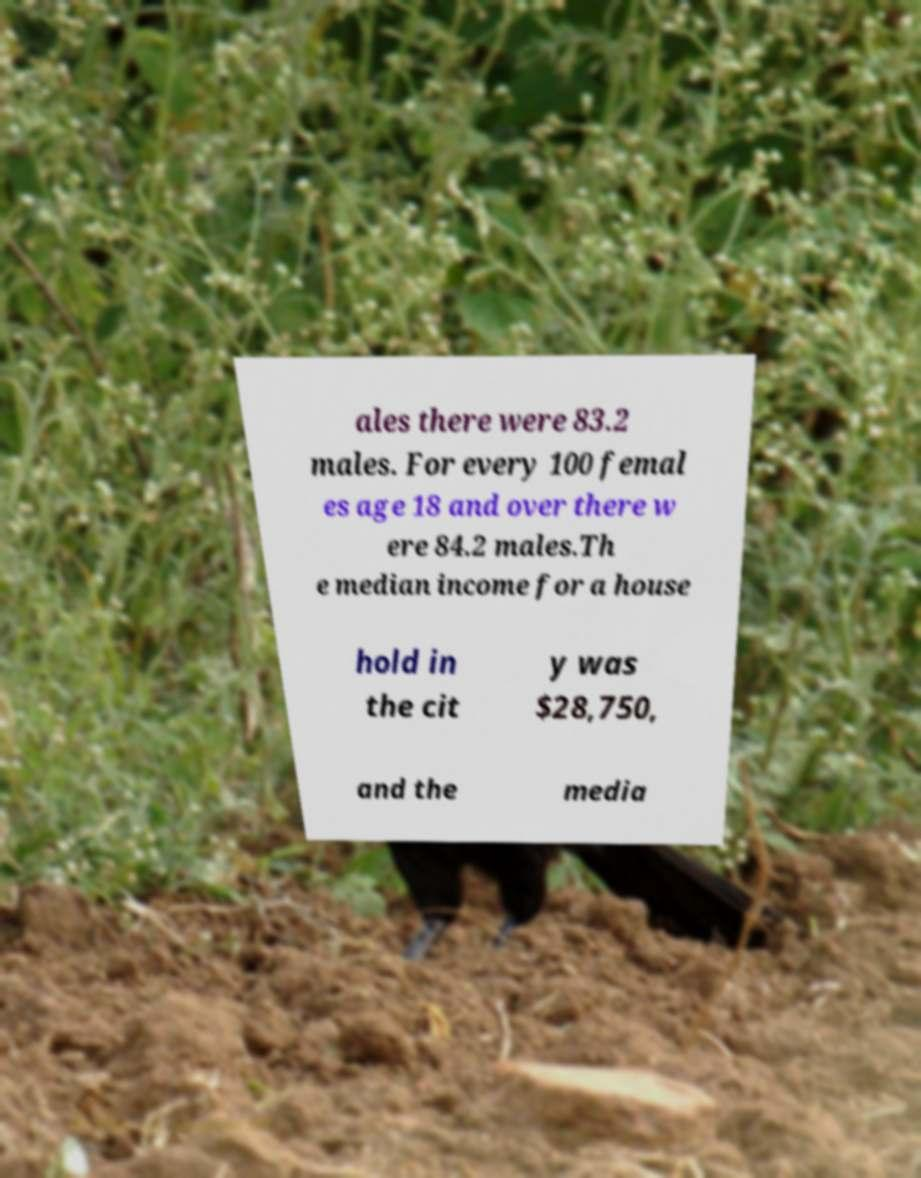Can you accurately transcribe the text from the provided image for me? ales there were 83.2 males. For every 100 femal es age 18 and over there w ere 84.2 males.Th e median income for a house hold in the cit y was $28,750, and the media 